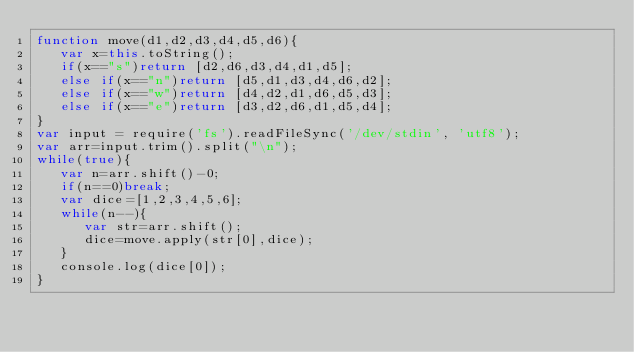Convert code to text. <code><loc_0><loc_0><loc_500><loc_500><_JavaScript_>function move(d1,d2,d3,d4,d5,d6){
   var x=this.toString();
   if(x=="s")return [d2,d6,d3,d4,d1,d5];
   else if(x=="n")return [d5,d1,d3,d4,d6,d2];
   else if(x=="w")return [d4,d2,d1,d6,d5,d3];
   else if(x=="e")return [d3,d2,d6,d1,d5,d4];
}
var input = require('fs').readFileSync('/dev/stdin', 'utf8');
var arr=input.trim().split("\n");
while(true){
   var n=arr.shift()-0;
   if(n==0)break;
   var dice=[1,2,3,4,5,6];
   while(n--){
      var str=arr.shift();
      dice=move.apply(str[0],dice);
   }
   console.log(dice[0]);
}</code> 